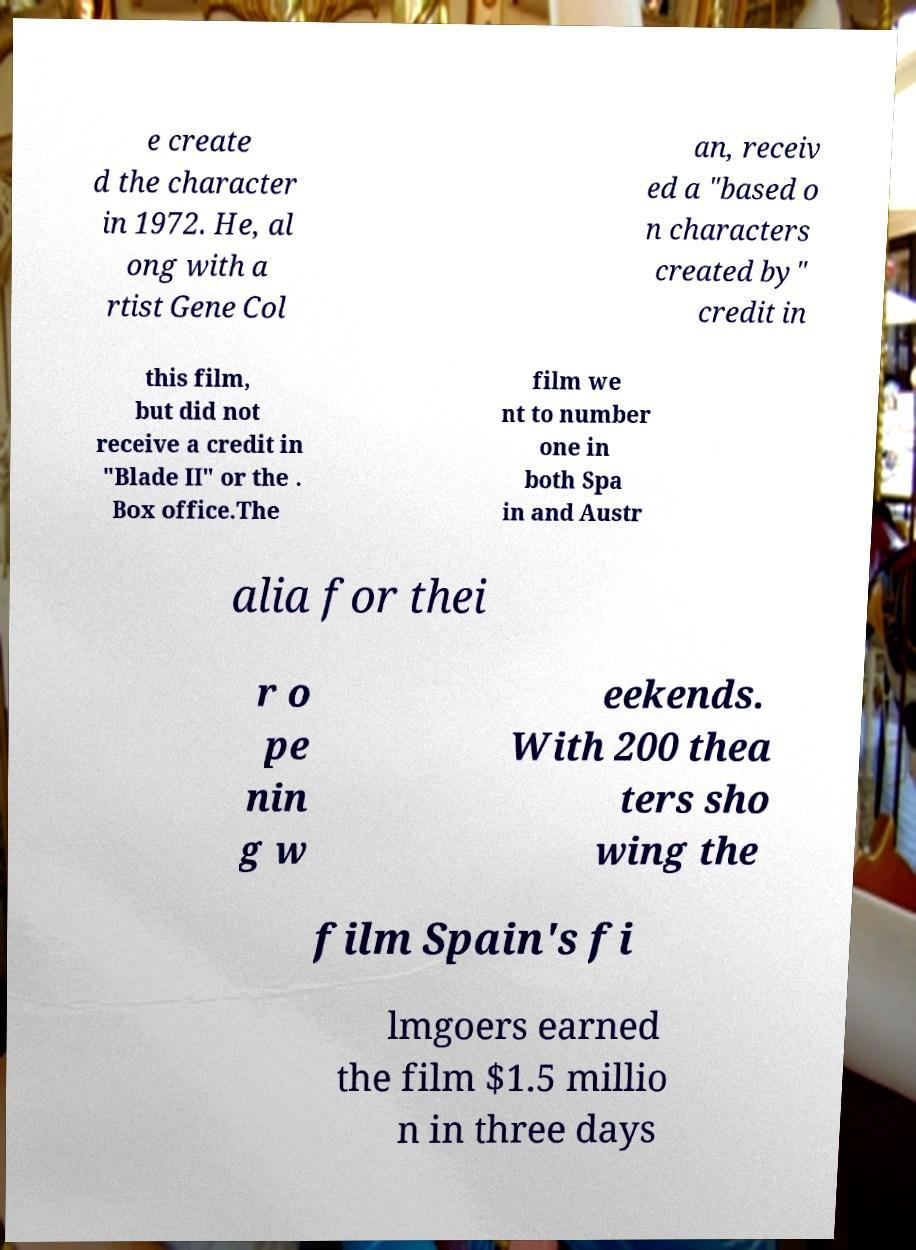For documentation purposes, I need the text within this image transcribed. Could you provide that? e create d the character in 1972. He, al ong with a rtist Gene Col an, receiv ed a "based o n characters created by" credit in this film, but did not receive a credit in "Blade II" or the . Box office.The film we nt to number one in both Spa in and Austr alia for thei r o pe nin g w eekends. With 200 thea ters sho wing the film Spain's fi lmgoers earned the film $1.5 millio n in three days 